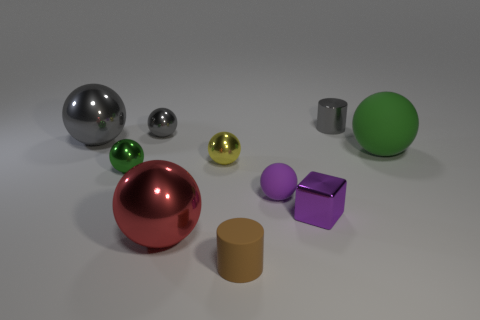The big thing that is right of the purple rubber object that is right of the big metallic sphere in front of the small purple block is made of what material?
Keep it short and to the point. Rubber. Does the cylinder that is left of the purple matte ball have the same material as the cylinder that is behind the green metal thing?
Give a very brief answer. No. How many matte objects are the same color as the tiny shiny cube?
Your answer should be compact. 1. Is the shape of the small gray thing in front of the shiny cylinder the same as  the red metallic object?
Offer a very short reply. Yes. Is there a small purple rubber object of the same shape as the large red shiny object?
Offer a very short reply. Yes. The gray object that is to the left of the small metallic ball behind the small yellow metal thing is what shape?
Your answer should be compact. Sphere. What is the color of the tiny sphere that is behind the yellow sphere?
Your answer should be very brief. Gray. What size is the purple cube that is made of the same material as the small gray cylinder?
Your answer should be very brief. Small. What size is the yellow thing that is the same shape as the large red shiny object?
Provide a short and direct response. Small. Are any big green matte things visible?
Your answer should be compact. Yes. 